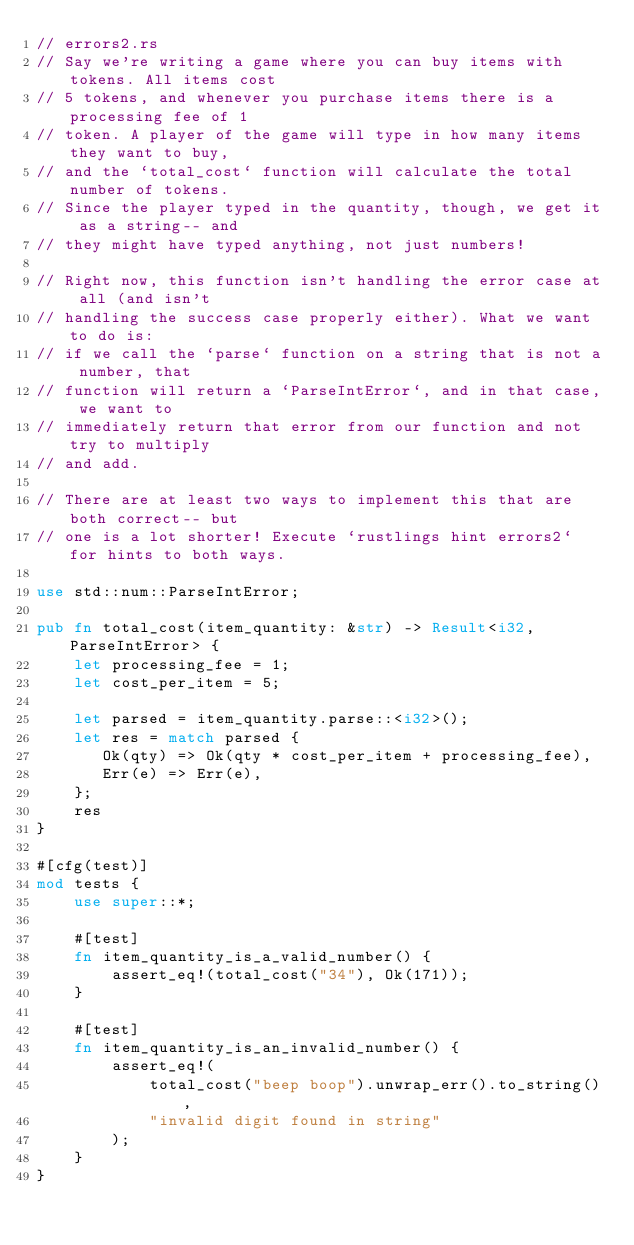<code> <loc_0><loc_0><loc_500><loc_500><_Rust_>// errors2.rs
// Say we're writing a game where you can buy items with tokens. All items cost
// 5 tokens, and whenever you purchase items there is a processing fee of 1
// token. A player of the game will type in how many items they want to buy,
// and the `total_cost` function will calculate the total number of tokens.
// Since the player typed in the quantity, though, we get it as a string-- and
// they might have typed anything, not just numbers!

// Right now, this function isn't handling the error case at all (and isn't
// handling the success case properly either). What we want to do is:
// if we call the `parse` function on a string that is not a number, that
// function will return a `ParseIntError`, and in that case, we want to
// immediately return that error from our function and not try to multiply
// and add.

// There are at least two ways to implement this that are both correct-- but
// one is a lot shorter! Execute `rustlings hint errors2` for hints to both ways.

use std::num::ParseIntError;

pub fn total_cost(item_quantity: &str) -> Result<i32, ParseIntError> {
    let processing_fee = 1;
    let cost_per_item = 5;
    
    let parsed = item_quantity.parse::<i32>();
    let res = match parsed {
       Ok(qty) => Ok(qty * cost_per_item + processing_fee),
       Err(e) => Err(e),
    };
    res
}

#[cfg(test)]
mod tests {
    use super::*;

    #[test]
    fn item_quantity_is_a_valid_number() {
        assert_eq!(total_cost("34"), Ok(171));
    }

    #[test]
    fn item_quantity_is_an_invalid_number() {
        assert_eq!(
            total_cost("beep boop").unwrap_err().to_string(),
            "invalid digit found in string"
        );
    }
}
</code> 